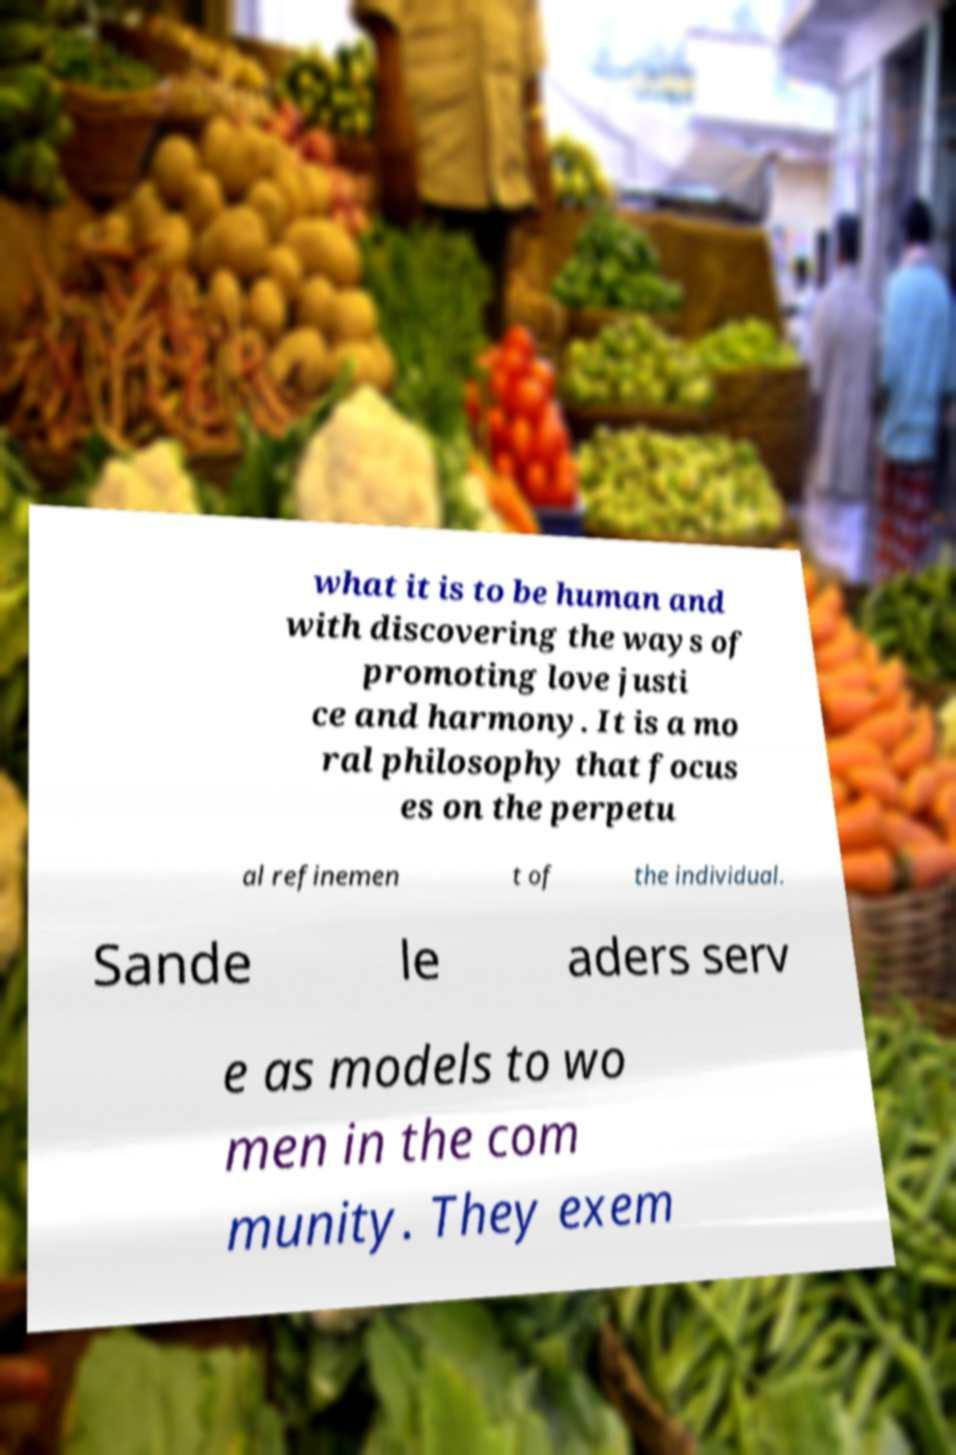Could you assist in decoding the text presented in this image and type it out clearly? what it is to be human and with discovering the ways of promoting love justi ce and harmony. It is a mo ral philosophy that focus es on the perpetu al refinemen t of the individual. Sande le aders serv e as models to wo men in the com munity. They exem 